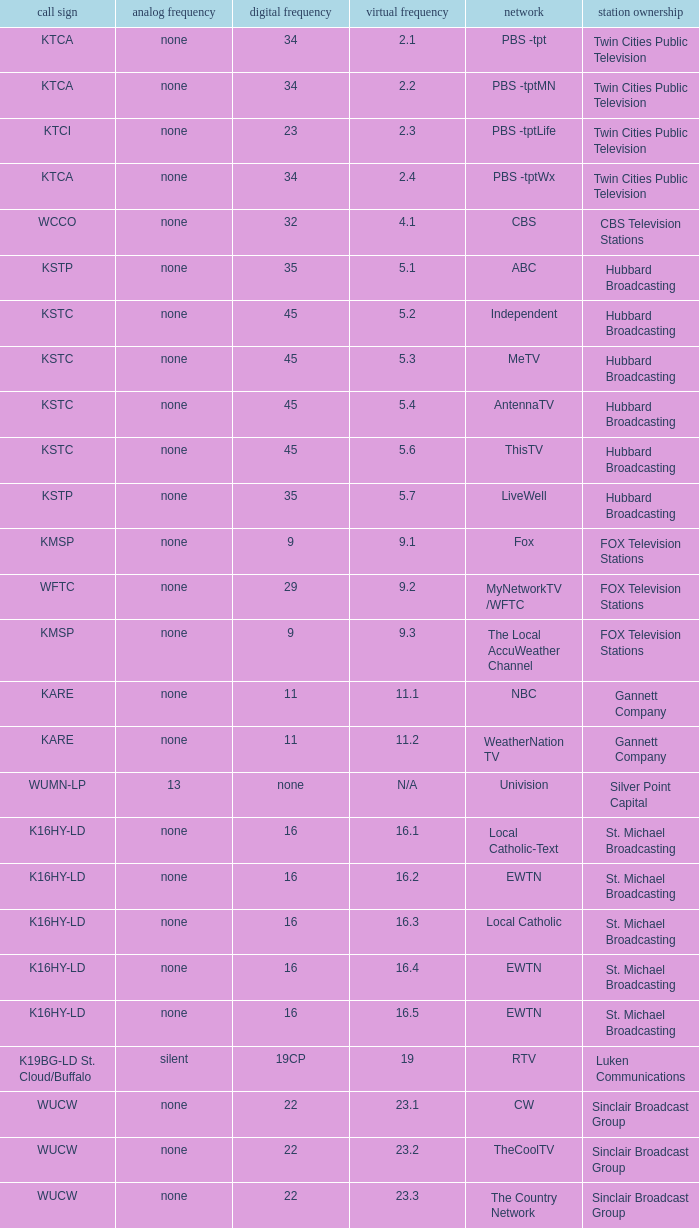Call sign of k33ln-ld, and a Virtual channel of 33.5 is what network? 3ABN Radio-Audio. 